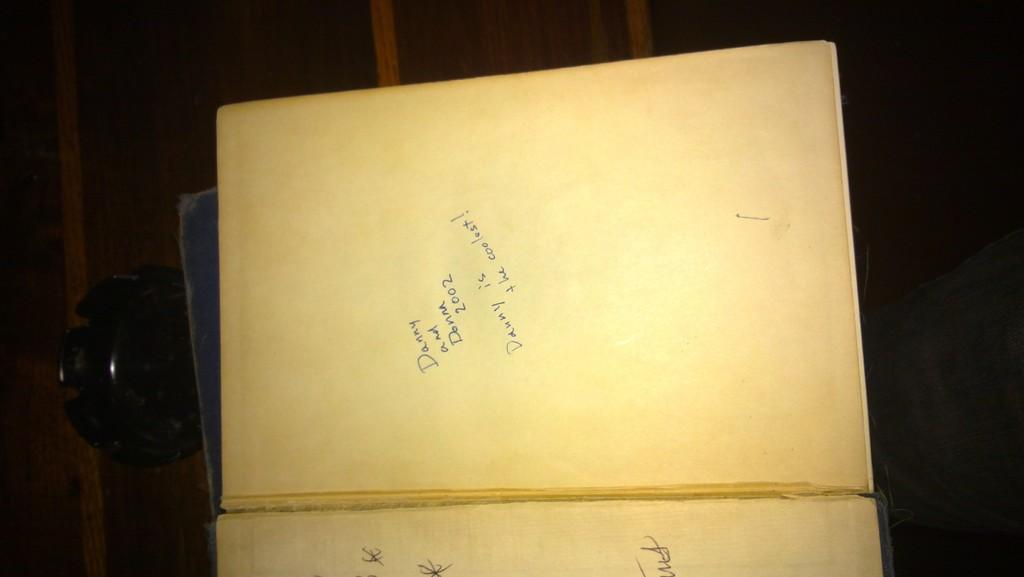<image>
Relay a brief, clear account of the picture shown. A book is open to a blank page that has hand written blue notes with the date 2002. 